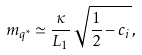Convert formula to latex. <formula><loc_0><loc_0><loc_500><loc_500>m _ { q ^ { * } } \simeq \frac { \kappa } { L _ { 1 } } \, \sqrt { \frac { 1 } { 2 } - c _ { i } } \, ,</formula> 